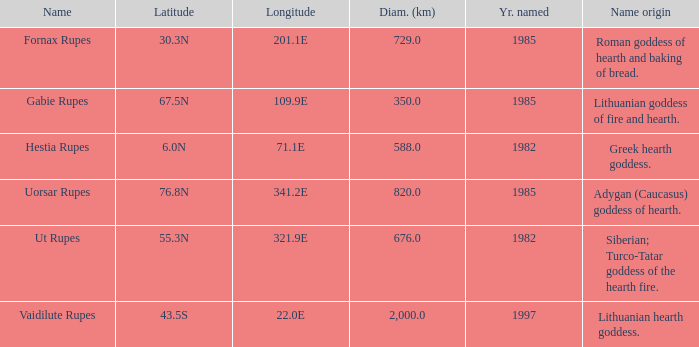At a longitude of 321.9e, what is the latitude of the features found? 55.3N. 